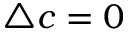<formula> <loc_0><loc_0><loc_500><loc_500>\triangle c = 0</formula> 